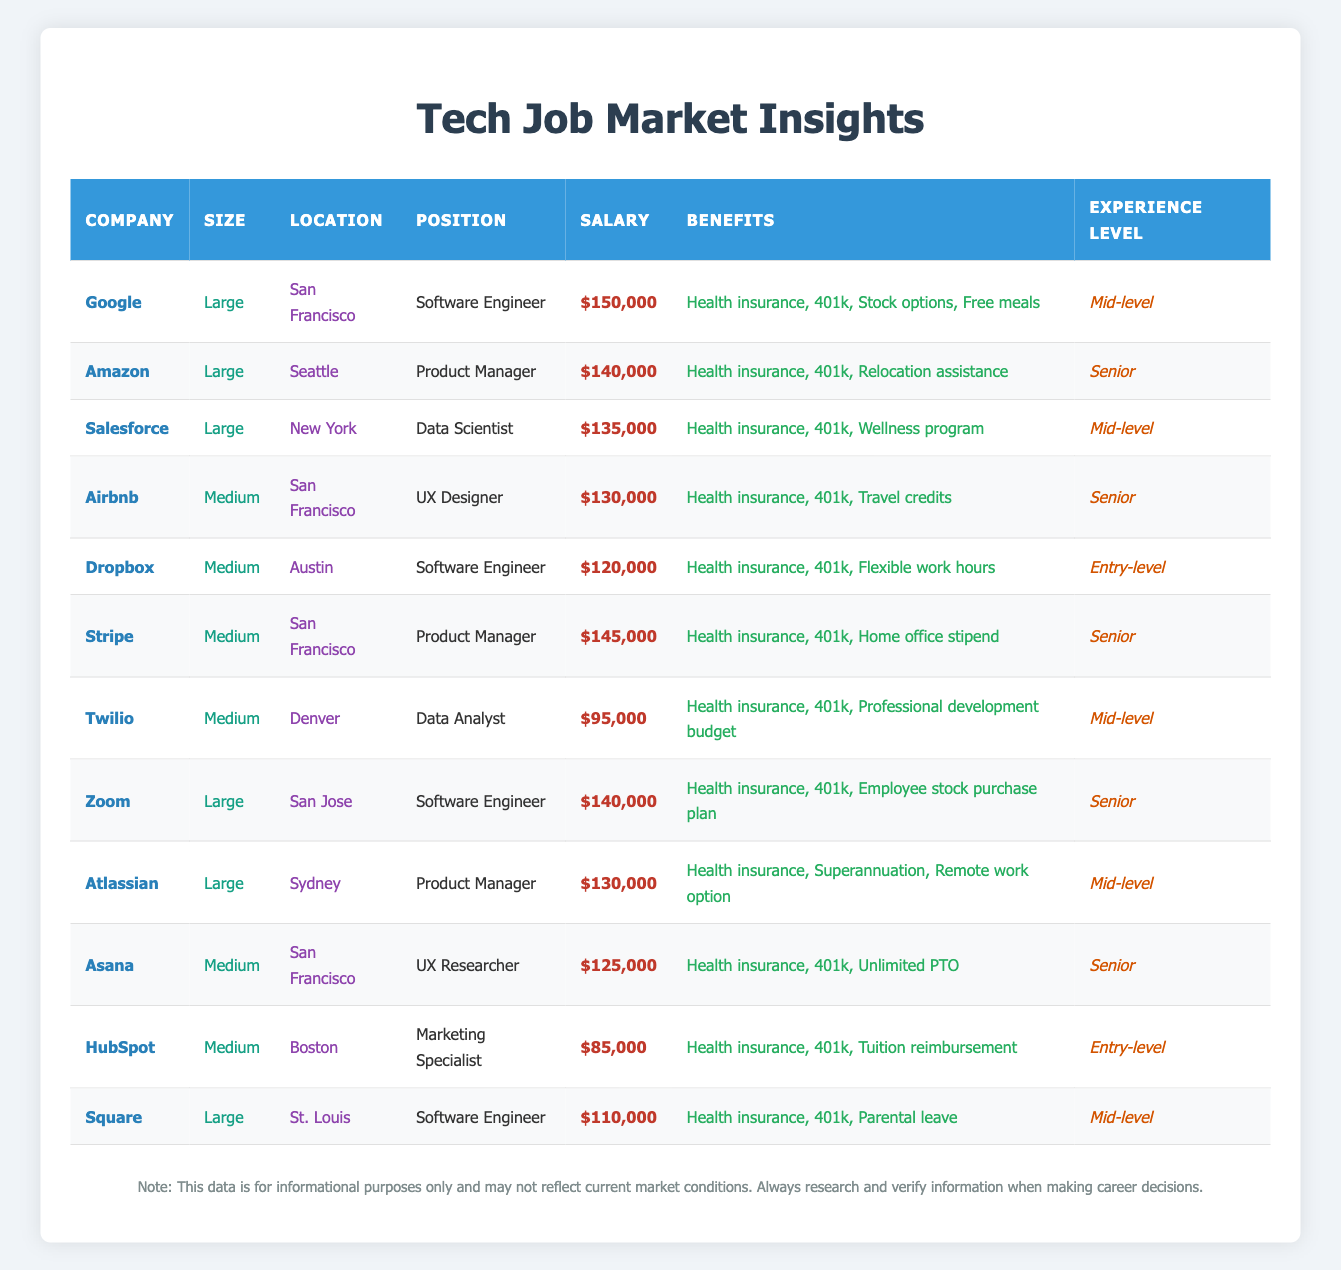What is the salary of the Software Engineer position at Google? The table shows that the salary for the Software Engineer position at Google is directly listed as $150,000.
Answer: $150,000 Which company has the highest salary for a medium-sized company? From the medium-sized companies listed in the table, I identified the salaries: Airbnb at $130,000, Stripe at $145,000, Dropbox at $120,000, Twilio at $95,000, Asana at $125,000, and HubSpot at $85,000. The highest among these is Stripe with a salary of $145,000.
Answer: Stripe with $145,000 Is it true that Salesforce offers a wellness program as part of its benefits? Looking at the row for Salesforce, the benefits listed include health insurance, 401k, and a wellness program. Since the wellness program is included, the statement is true.
Answer: Yes What is the average salary of Software Engineers listed in the table? The table lists three Software Engineer positions with the following salaries: Google ($150,000), Zoom ($140,000), and Square ($110,000). Adding these gives $150,000 + $140,000 + $110,000 = $400,000. Since there are three positions, the average salary is $400,000 / 3 = $133,333.33.
Answer: $133,333.33 Which location corresponds to the lowest salary for an entry-level position? The only entry-level position in the table is the Marketing Specialist at HubSpot, located in Boston, with a salary of $85,000. No other entry-level positions are listed, so this is the lowest.
Answer: Boston with $85,000 How many companies in San Francisco offer a salary greater than $130,000? The data shows that Google ($150,000), Airbnb ($130,000), and Stripe ($145,000) are in San Francisco. Since Airbnb's salary is equal to $130,000 and not greater, the companies offering salaries greater than this are Google and Stripe. Thus, there are 2 companies.
Answer: 2 Is Dropbox the only medium-sized company located in Austin? The table has only one entry for Dropbox as a medium-sized company located in Austin with a salary of $120,000. No other medium-sized companies in Austin are listed here, so the statement is true.
Answer: Yes What is the total number of benefits offered by all companies listed? Each company listed offers different benefits; counting the unique benefits gives: Google (4), Amazon (3), Salesforce (3), Airbnb (3), Dropbox (3), Stripe (3), Twilio (3), Zoom (3), Atlassian (3), Asana (3), HubSpot (3), and Square (3). Adding these yields a total of 4 + 3 + 3 + 3 + 3 + 3 + 3 + 3 + 3 + 3 + 3 + 3 = 36.
Answer: 36 